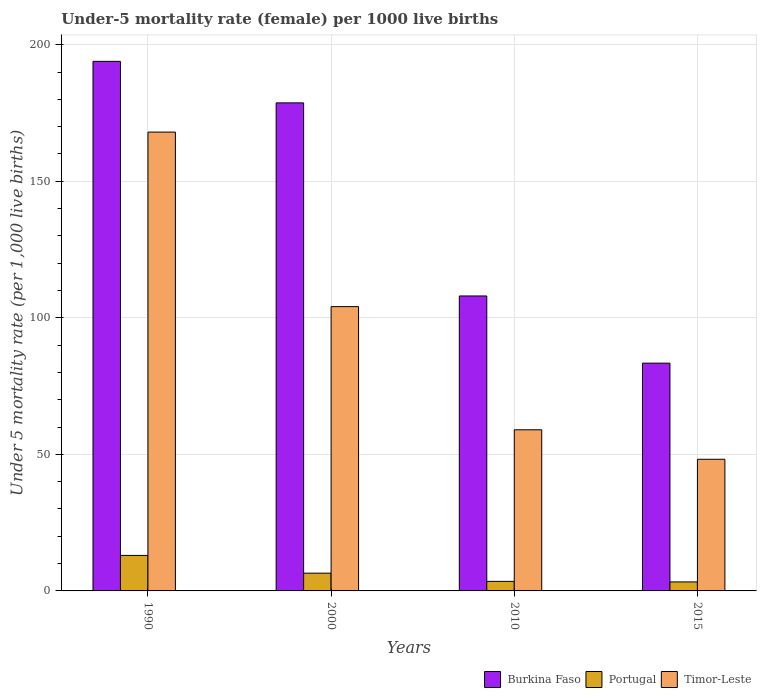Are the number of bars on each tick of the X-axis equal?
Your answer should be compact. Yes. How many bars are there on the 3rd tick from the left?
Your answer should be very brief. 3. How many bars are there on the 1st tick from the right?
Your response must be concise. 3. What is the label of the 2nd group of bars from the left?
Offer a very short reply. 2000. Across all years, what is the maximum under-five mortality rate in Burkina Faso?
Your answer should be compact. 193.9. Across all years, what is the minimum under-five mortality rate in Burkina Faso?
Keep it short and to the point. 83.4. In which year was the under-five mortality rate in Portugal maximum?
Make the answer very short. 1990. In which year was the under-five mortality rate in Portugal minimum?
Offer a very short reply. 2015. What is the total under-five mortality rate in Portugal in the graph?
Give a very brief answer. 26.3. What is the difference between the under-five mortality rate in Burkina Faso in 2010 and that in 2015?
Keep it short and to the point. 24.6. What is the difference between the under-five mortality rate in Portugal in 2000 and the under-five mortality rate in Burkina Faso in 2015?
Offer a terse response. -76.9. What is the average under-five mortality rate in Portugal per year?
Provide a short and direct response. 6.58. In the year 2000, what is the difference between the under-five mortality rate in Burkina Faso and under-five mortality rate in Timor-Leste?
Your response must be concise. 74.6. In how many years, is the under-five mortality rate in Burkina Faso greater than 20?
Your answer should be very brief. 4. What is the ratio of the under-five mortality rate in Portugal in 2000 to that in 2015?
Ensure brevity in your answer.  1.97. Is the difference between the under-five mortality rate in Burkina Faso in 2010 and 2015 greater than the difference between the under-five mortality rate in Timor-Leste in 2010 and 2015?
Your answer should be very brief. Yes. What is the difference between the highest and the second highest under-five mortality rate in Portugal?
Keep it short and to the point. 6.5. What is the difference between the highest and the lowest under-five mortality rate in Timor-Leste?
Offer a very short reply. 119.8. What does the 1st bar from the left in 2000 represents?
Make the answer very short. Burkina Faso. What does the 3rd bar from the right in 1990 represents?
Provide a short and direct response. Burkina Faso. Is it the case that in every year, the sum of the under-five mortality rate in Portugal and under-five mortality rate in Burkina Faso is greater than the under-five mortality rate in Timor-Leste?
Keep it short and to the point. Yes. How many bars are there?
Offer a very short reply. 12. How many years are there in the graph?
Offer a very short reply. 4. Does the graph contain any zero values?
Your answer should be compact. No. Where does the legend appear in the graph?
Offer a terse response. Bottom right. What is the title of the graph?
Make the answer very short. Under-5 mortality rate (female) per 1000 live births. What is the label or title of the X-axis?
Give a very brief answer. Years. What is the label or title of the Y-axis?
Keep it short and to the point. Under 5 mortality rate (per 1,0 live births). What is the Under 5 mortality rate (per 1,000 live births) of Burkina Faso in 1990?
Offer a very short reply. 193.9. What is the Under 5 mortality rate (per 1,000 live births) in Timor-Leste in 1990?
Your answer should be very brief. 168. What is the Under 5 mortality rate (per 1,000 live births) of Burkina Faso in 2000?
Keep it short and to the point. 178.7. What is the Under 5 mortality rate (per 1,000 live births) in Timor-Leste in 2000?
Make the answer very short. 104.1. What is the Under 5 mortality rate (per 1,000 live births) in Burkina Faso in 2010?
Provide a short and direct response. 108. What is the Under 5 mortality rate (per 1,000 live births) of Portugal in 2010?
Provide a succinct answer. 3.5. What is the Under 5 mortality rate (per 1,000 live births) in Burkina Faso in 2015?
Give a very brief answer. 83.4. What is the Under 5 mortality rate (per 1,000 live births) of Timor-Leste in 2015?
Provide a short and direct response. 48.2. Across all years, what is the maximum Under 5 mortality rate (per 1,000 live births) of Burkina Faso?
Provide a succinct answer. 193.9. Across all years, what is the maximum Under 5 mortality rate (per 1,000 live births) of Portugal?
Offer a very short reply. 13. Across all years, what is the maximum Under 5 mortality rate (per 1,000 live births) of Timor-Leste?
Give a very brief answer. 168. Across all years, what is the minimum Under 5 mortality rate (per 1,000 live births) in Burkina Faso?
Ensure brevity in your answer.  83.4. Across all years, what is the minimum Under 5 mortality rate (per 1,000 live births) of Timor-Leste?
Provide a succinct answer. 48.2. What is the total Under 5 mortality rate (per 1,000 live births) of Burkina Faso in the graph?
Your response must be concise. 564. What is the total Under 5 mortality rate (per 1,000 live births) in Portugal in the graph?
Make the answer very short. 26.3. What is the total Under 5 mortality rate (per 1,000 live births) in Timor-Leste in the graph?
Your response must be concise. 379.3. What is the difference between the Under 5 mortality rate (per 1,000 live births) of Burkina Faso in 1990 and that in 2000?
Your response must be concise. 15.2. What is the difference between the Under 5 mortality rate (per 1,000 live births) in Portugal in 1990 and that in 2000?
Make the answer very short. 6.5. What is the difference between the Under 5 mortality rate (per 1,000 live births) in Timor-Leste in 1990 and that in 2000?
Keep it short and to the point. 63.9. What is the difference between the Under 5 mortality rate (per 1,000 live births) of Burkina Faso in 1990 and that in 2010?
Your answer should be very brief. 85.9. What is the difference between the Under 5 mortality rate (per 1,000 live births) in Portugal in 1990 and that in 2010?
Offer a terse response. 9.5. What is the difference between the Under 5 mortality rate (per 1,000 live births) of Timor-Leste in 1990 and that in 2010?
Provide a succinct answer. 109. What is the difference between the Under 5 mortality rate (per 1,000 live births) in Burkina Faso in 1990 and that in 2015?
Provide a short and direct response. 110.5. What is the difference between the Under 5 mortality rate (per 1,000 live births) of Portugal in 1990 and that in 2015?
Provide a short and direct response. 9.7. What is the difference between the Under 5 mortality rate (per 1,000 live births) in Timor-Leste in 1990 and that in 2015?
Provide a short and direct response. 119.8. What is the difference between the Under 5 mortality rate (per 1,000 live births) of Burkina Faso in 2000 and that in 2010?
Give a very brief answer. 70.7. What is the difference between the Under 5 mortality rate (per 1,000 live births) of Timor-Leste in 2000 and that in 2010?
Your response must be concise. 45.1. What is the difference between the Under 5 mortality rate (per 1,000 live births) of Burkina Faso in 2000 and that in 2015?
Offer a terse response. 95.3. What is the difference between the Under 5 mortality rate (per 1,000 live births) of Timor-Leste in 2000 and that in 2015?
Offer a very short reply. 55.9. What is the difference between the Under 5 mortality rate (per 1,000 live births) of Burkina Faso in 2010 and that in 2015?
Offer a very short reply. 24.6. What is the difference between the Under 5 mortality rate (per 1,000 live births) in Portugal in 2010 and that in 2015?
Ensure brevity in your answer.  0.2. What is the difference between the Under 5 mortality rate (per 1,000 live births) in Burkina Faso in 1990 and the Under 5 mortality rate (per 1,000 live births) in Portugal in 2000?
Keep it short and to the point. 187.4. What is the difference between the Under 5 mortality rate (per 1,000 live births) of Burkina Faso in 1990 and the Under 5 mortality rate (per 1,000 live births) of Timor-Leste in 2000?
Provide a succinct answer. 89.8. What is the difference between the Under 5 mortality rate (per 1,000 live births) in Portugal in 1990 and the Under 5 mortality rate (per 1,000 live births) in Timor-Leste in 2000?
Offer a very short reply. -91.1. What is the difference between the Under 5 mortality rate (per 1,000 live births) in Burkina Faso in 1990 and the Under 5 mortality rate (per 1,000 live births) in Portugal in 2010?
Give a very brief answer. 190.4. What is the difference between the Under 5 mortality rate (per 1,000 live births) in Burkina Faso in 1990 and the Under 5 mortality rate (per 1,000 live births) in Timor-Leste in 2010?
Your response must be concise. 134.9. What is the difference between the Under 5 mortality rate (per 1,000 live births) in Portugal in 1990 and the Under 5 mortality rate (per 1,000 live births) in Timor-Leste in 2010?
Your answer should be compact. -46. What is the difference between the Under 5 mortality rate (per 1,000 live births) of Burkina Faso in 1990 and the Under 5 mortality rate (per 1,000 live births) of Portugal in 2015?
Make the answer very short. 190.6. What is the difference between the Under 5 mortality rate (per 1,000 live births) in Burkina Faso in 1990 and the Under 5 mortality rate (per 1,000 live births) in Timor-Leste in 2015?
Your answer should be compact. 145.7. What is the difference between the Under 5 mortality rate (per 1,000 live births) in Portugal in 1990 and the Under 5 mortality rate (per 1,000 live births) in Timor-Leste in 2015?
Offer a terse response. -35.2. What is the difference between the Under 5 mortality rate (per 1,000 live births) of Burkina Faso in 2000 and the Under 5 mortality rate (per 1,000 live births) of Portugal in 2010?
Provide a short and direct response. 175.2. What is the difference between the Under 5 mortality rate (per 1,000 live births) of Burkina Faso in 2000 and the Under 5 mortality rate (per 1,000 live births) of Timor-Leste in 2010?
Provide a short and direct response. 119.7. What is the difference between the Under 5 mortality rate (per 1,000 live births) of Portugal in 2000 and the Under 5 mortality rate (per 1,000 live births) of Timor-Leste in 2010?
Keep it short and to the point. -52.5. What is the difference between the Under 5 mortality rate (per 1,000 live births) of Burkina Faso in 2000 and the Under 5 mortality rate (per 1,000 live births) of Portugal in 2015?
Provide a short and direct response. 175.4. What is the difference between the Under 5 mortality rate (per 1,000 live births) in Burkina Faso in 2000 and the Under 5 mortality rate (per 1,000 live births) in Timor-Leste in 2015?
Offer a terse response. 130.5. What is the difference between the Under 5 mortality rate (per 1,000 live births) of Portugal in 2000 and the Under 5 mortality rate (per 1,000 live births) of Timor-Leste in 2015?
Provide a short and direct response. -41.7. What is the difference between the Under 5 mortality rate (per 1,000 live births) of Burkina Faso in 2010 and the Under 5 mortality rate (per 1,000 live births) of Portugal in 2015?
Keep it short and to the point. 104.7. What is the difference between the Under 5 mortality rate (per 1,000 live births) in Burkina Faso in 2010 and the Under 5 mortality rate (per 1,000 live births) in Timor-Leste in 2015?
Provide a short and direct response. 59.8. What is the difference between the Under 5 mortality rate (per 1,000 live births) of Portugal in 2010 and the Under 5 mortality rate (per 1,000 live births) of Timor-Leste in 2015?
Offer a terse response. -44.7. What is the average Under 5 mortality rate (per 1,000 live births) of Burkina Faso per year?
Ensure brevity in your answer.  141. What is the average Under 5 mortality rate (per 1,000 live births) in Portugal per year?
Give a very brief answer. 6.58. What is the average Under 5 mortality rate (per 1,000 live births) in Timor-Leste per year?
Your answer should be very brief. 94.83. In the year 1990, what is the difference between the Under 5 mortality rate (per 1,000 live births) in Burkina Faso and Under 5 mortality rate (per 1,000 live births) in Portugal?
Provide a short and direct response. 180.9. In the year 1990, what is the difference between the Under 5 mortality rate (per 1,000 live births) of Burkina Faso and Under 5 mortality rate (per 1,000 live births) of Timor-Leste?
Make the answer very short. 25.9. In the year 1990, what is the difference between the Under 5 mortality rate (per 1,000 live births) in Portugal and Under 5 mortality rate (per 1,000 live births) in Timor-Leste?
Provide a succinct answer. -155. In the year 2000, what is the difference between the Under 5 mortality rate (per 1,000 live births) in Burkina Faso and Under 5 mortality rate (per 1,000 live births) in Portugal?
Your response must be concise. 172.2. In the year 2000, what is the difference between the Under 5 mortality rate (per 1,000 live births) in Burkina Faso and Under 5 mortality rate (per 1,000 live births) in Timor-Leste?
Make the answer very short. 74.6. In the year 2000, what is the difference between the Under 5 mortality rate (per 1,000 live births) of Portugal and Under 5 mortality rate (per 1,000 live births) of Timor-Leste?
Give a very brief answer. -97.6. In the year 2010, what is the difference between the Under 5 mortality rate (per 1,000 live births) in Burkina Faso and Under 5 mortality rate (per 1,000 live births) in Portugal?
Keep it short and to the point. 104.5. In the year 2010, what is the difference between the Under 5 mortality rate (per 1,000 live births) of Burkina Faso and Under 5 mortality rate (per 1,000 live births) of Timor-Leste?
Offer a very short reply. 49. In the year 2010, what is the difference between the Under 5 mortality rate (per 1,000 live births) in Portugal and Under 5 mortality rate (per 1,000 live births) in Timor-Leste?
Keep it short and to the point. -55.5. In the year 2015, what is the difference between the Under 5 mortality rate (per 1,000 live births) in Burkina Faso and Under 5 mortality rate (per 1,000 live births) in Portugal?
Offer a terse response. 80.1. In the year 2015, what is the difference between the Under 5 mortality rate (per 1,000 live births) of Burkina Faso and Under 5 mortality rate (per 1,000 live births) of Timor-Leste?
Your answer should be compact. 35.2. In the year 2015, what is the difference between the Under 5 mortality rate (per 1,000 live births) of Portugal and Under 5 mortality rate (per 1,000 live births) of Timor-Leste?
Offer a very short reply. -44.9. What is the ratio of the Under 5 mortality rate (per 1,000 live births) in Burkina Faso in 1990 to that in 2000?
Your response must be concise. 1.09. What is the ratio of the Under 5 mortality rate (per 1,000 live births) of Timor-Leste in 1990 to that in 2000?
Keep it short and to the point. 1.61. What is the ratio of the Under 5 mortality rate (per 1,000 live births) of Burkina Faso in 1990 to that in 2010?
Make the answer very short. 1.8. What is the ratio of the Under 5 mortality rate (per 1,000 live births) of Portugal in 1990 to that in 2010?
Offer a terse response. 3.71. What is the ratio of the Under 5 mortality rate (per 1,000 live births) in Timor-Leste in 1990 to that in 2010?
Provide a short and direct response. 2.85. What is the ratio of the Under 5 mortality rate (per 1,000 live births) of Burkina Faso in 1990 to that in 2015?
Give a very brief answer. 2.32. What is the ratio of the Under 5 mortality rate (per 1,000 live births) of Portugal in 1990 to that in 2015?
Your answer should be very brief. 3.94. What is the ratio of the Under 5 mortality rate (per 1,000 live births) in Timor-Leste in 1990 to that in 2015?
Provide a short and direct response. 3.49. What is the ratio of the Under 5 mortality rate (per 1,000 live births) of Burkina Faso in 2000 to that in 2010?
Your answer should be very brief. 1.65. What is the ratio of the Under 5 mortality rate (per 1,000 live births) of Portugal in 2000 to that in 2010?
Your answer should be compact. 1.86. What is the ratio of the Under 5 mortality rate (per 1,000 live births) of Timor-Leste in 2000 to that in 2010?
Offer a very short reply. 1.76. What is the ratio of the Under 5 mortality rate (per 1,000 live births) of Burkina Faso in 2000 to that in 2015?
Your response must be concise. 2.14. What is the ratio of the Under 5 mortality rate (per 1,000 live births) of Portugal in 2000 to that in 2015?
Provide a short and direct response. 1.97. What is the ratio of the Under 5 mortality rate (per 1,000 live births) of Timor-Leste in 2000 to that in 2015?
Your answer should be compact. 2.16. What is the ratio of the Under 5 mortality rate (per 1,000 live births) in Burkina Faso in 2010 to that in 2015?
Provide a short and direct response. 1.29. What is the ratio of the Under 5 mortality rate (per 1,000 live births) of Portugal in 2010 to that in 2015?
Your answer should be very brief. 1.06. What is the ratio of the Under 5 mortality rate (per 1,000 live births) in Timor-Leste in 2010 to that in 2015?
Offer a very short reply. 1.22. What is the difference between the highest and the second highest Under 5 mortality rate (per 1,000 live births) in Burkina Faso?
Your response must be concise. 15.2. What is the difference between the highest and the second highest Under 5 mortality rate (per 1,000 live births) of Portugal?
Give a very brief answer. 6.5. What is the difference between the highest and the second highest Under 5 mortality rate (per 1,000 live births) in Timor-Leste?
Make the answer very short. 63.9. What is the difference between the highest and the lowest Under 5 mortality rate (per 1,000 live births) in Burkina Faso?
Make the answer very short. 110.5. What is the difference between the highest and the lowest Under 5 mortality rate (per 1,000 live births) in Timor-Leste?
Make the answer very short. 119.8. 